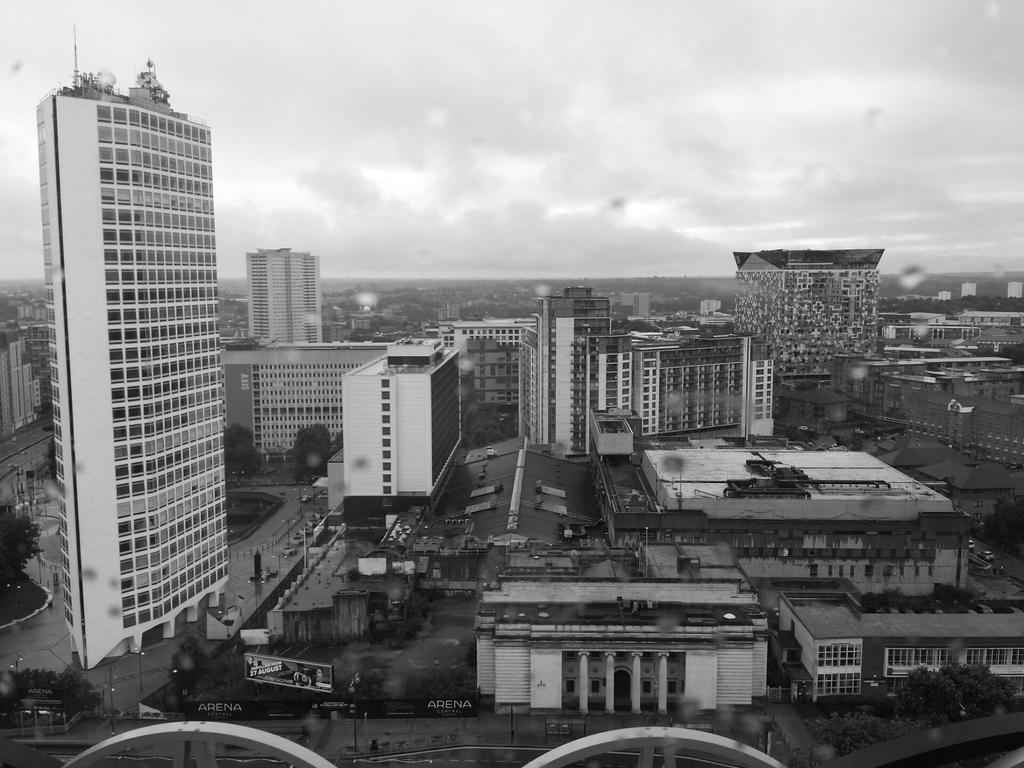Could you give a brief overview of what you see in this image? This picture is clicked outside. In the center we can see the buildings, trees, text on the hoarding and we can see the lamp posts, ground and many other objects. In the background we can see the sky which is full of clouds and we can see many other objects. 